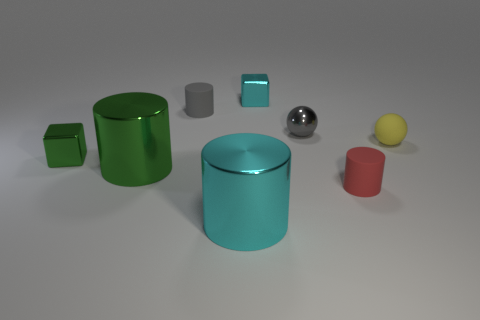What number of objects are either red cylinders or cyan shiny cylinders? In the image, there is only one cyan shiny cylinder and no red cylinders. Therefore, the correct number of objects that are either red cylinders or cyan shiny cylinders is 1. 